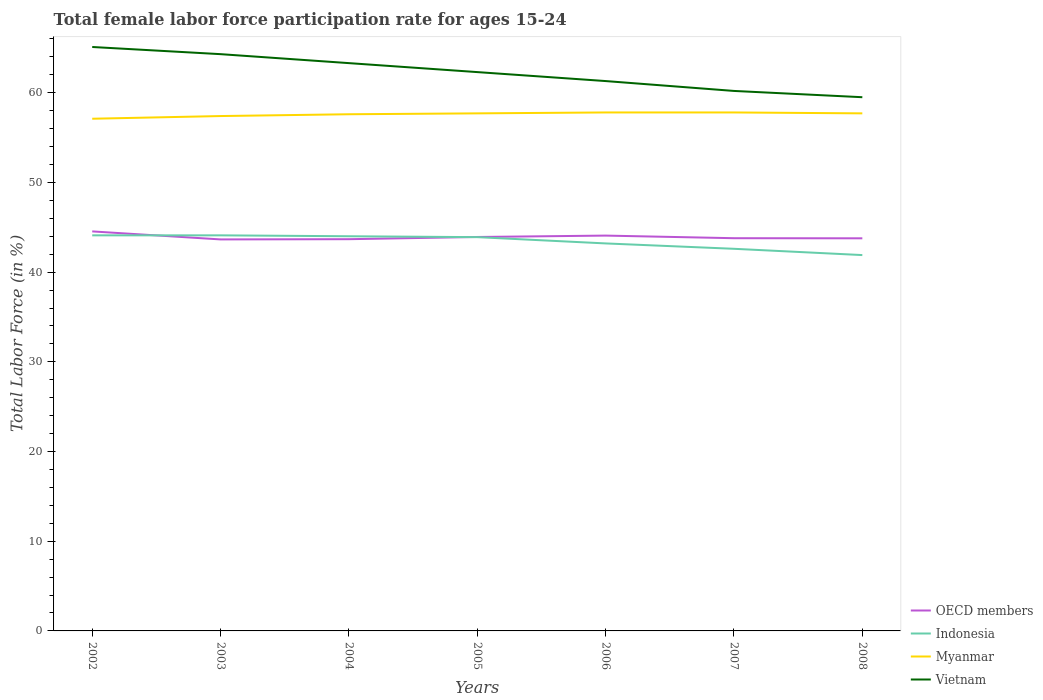How many different coloured lines are there?
Ensure brevity in your answer.  4. Across all years, what is the maximum female labor force participation rate in OECD members?
Keep it short and to the point. 43.65. What is the total female labor force participation rate in Vietnam in the graph?
Make the answer very short. 0.8. What is the difference between the highest and the second highest female labor force participation rate in Indonesia?
Ensure brevity in your answer.  2.2. What is the difference between the highest and the lowest female labor force participation rate in Vietnam?
Offer a very short reply. 4. Is the female labor force participation rate in Indonesia strictly greater than the female labor force participation rate in Vietnam over the years?
Offer a very short reply. Yes. How many lines are there?
Your answer should be compact. 4. How many years are there in the graph?
Offer a terse response. 7. Does the graph contain any zero values?
Your response must be concise. No. Where does the legend appear in the graph?
Your response must be concise. Bottom right. How many legend labels are there?
Your answer should be compact. 4. How are the legend labels stacked?
Provide a succinct answer. Vertical. What is the title of the graph?
Provide a short and direct response. Total female labor force participation rate for ages 15-24. Does "Ireland" appear as one of the legend labels in the graph?
Provide a short and direct response. No. What is the label or title of the X-axis?
Make the answer very short. Years. What is the label or title of the Y-axis?
Your answer should be very brief. Total Labor Force (in %). What is the Total Labor Force (in %) of OECD members in 2002?
Keep it short and to the point. 44.54. What is the Total Labor Force (in %) in Indonesia in 2002?
Provide a succinct answer. 44.1. What is the Total Labor Force (in %) in Myanmar in 2002?
Your answer should be very brief. 57.1. What is the Total Labor Force (in %) in Vietnam in 2002?
Keep it short and to the point. 65.1. What is the Total Labor Force (in %) of OECD members in 2003?
Make the answer very short. 43.65. What is the Total Labor Force (in %) of Indonesia in 2003?
Make the answer very short. 44.1. What is the Total Labor Force (in %) of Myanmar in 2003?
Your answer should be very brief. 57.4. What is the Total Labor Force (in %) of Vietnam in 2003?
Your response must be concise. 64.3. What is the Total Labor Force (in %) in OECD members in 2004?
Give a very brief answer. 43.67. What is the Total Labor Force (in %) of Myanmar in 2004?
Provide a succinct answer. 57.6. What is the Total Labor Force (in %) of Vietnam in 2004?
Provide a short and direct response. 63.3. What is the Total Labor Force (in %) of OECD members in 2005?
Your answer should be very brief. 43.92. What is the Total Labor Force (in %) of Indonesia in 2005?
Offer a very short reply. 43.9. What is the Total Labor Force (in %) in Myanmar in 2005?
Ensure brevity in your answer.  57.7. What is the Total Labor Force (in %) in Vietnam in 2005?
Offer a very short reply. 62.3. What is the Total Labor Force (in %) of OECD members in 2006?
Your answer should be compact. 44.07. What is the Total Labor Force (in %) in Indonesia in 2006?
Your answer should be compact. 43.2. What is the Total Labor Force (in %) in Myanmar in 2006?
Provide a succinct answer. 57.8. What is the Total Labor Force (in %) in Vietnam in 2006?
Give a very brief answer. 61.3. What is the Total Labor Force (in %) of OECD members in 2007?
Keep it short and to the point. 43.78. What is the Total Labor Force (in %) in Indonesia in 2007?
Your answer should be very brief. 42.6. What is the Total Labor Force (in %) in Myanmar in 2007?
Provide a short and direct response. 57.8. What is the Total Labor Force (in %) in Vietnam in 2007?
Give a very brief answer. 60.2. What is the Total Labor Force (in %) of OECD members in 2008?
Offer a very short reply. 43.77. What is the Total Labor Force (in %) in Indonesia in 2008?
Make the answer very short. 41.9. What is the Total Labor Force (in %) of Myanmar in 2008?
Provide a succinct answer. 57.7. What is the Total Labor Force (in %) in Vietnam in 2008?
Your answer should be very brief. 59.5. Across all years, what is the maximum Total Labor Force (in %) of OECD members?
Give a very brief answer. 44.54. Across all years, what is the maximum Total Labor Force (in %) of Indonesia?
Your answer should be very brief. 44.1. Across all years, what is the maximum Total Labor Force (in %) in Myanmar?
Provide a short and direct response. 57.8. Across all years, what is the maximum Total Labor Force (in %) of Vietnam?
Keep it short and to the point. 65.1. Across all years, what is the minimum Total Labor Force (in %) of OECD members?
Keep it short and to the point. 43.65. Across all years, what is the minimum Total Labor Force (in %) of Indonesia?
Your answer should be very brief. 41.9. Across all years, what is the minimum Total Labor Force (in %) in Myanmar?
Offer a terse response. 57.1. Across all years, what is the minimum Total Labor Force (in %) in Vietnam?
Provide a short and direct response. 59.5. What is the total Total Labor Force (in %) in OECD members in the graph?
Your answer should be very brief. 307.4. What is the total Total Labor Force (in %) in Indonesia in the graph?
Give a very brief answer. 303.8. What is the total Total Labor Force (in %) of Myanmar in the graph?
Ensure brevity in your answer.  403.1. What is the total Total Labor Force (in %) in Vietnam in the graph?
Your answer should be very brief. 436. What is the difference between the Total Labor Force (in %) of OECD members in 2002 and that in 2003?
Provide a short and direct response. 0.89. What is the difference between the Total Labor Force (in %) of Indonesia in 2002 and that in 2003?
Ensure brevity in your answer.  0. What is the difference between the Total Labor Force (in %) of OECD members in 2002 and that in 2004?
Offer a very short reply. 0.87. What is the difference between the Total Labor Force (in %) of Vietnam in 2002 and that in 2004?
Give a very brief answer. 1.8. What is the difference between the Total Labor Force (in %) of OECD members in 2002 and that in 2005?
Give a very brief answer. 0.62. What is the difference between the Total Labor Force (in %) of Myanmar in 2002 and that in 2005?
Offer a very short reply. -0.6. What is the difference between the Total Labor Force (in %) of OECD members in 2002 and that in 2006?
Make the answer very short. 0.47. What is the difference between the Total Labor Force (in %) of Vietnam in 2002 and that in 2006?
Your response must be concise. 3.8. What is the difference between the Total Labor Force (in %) in OECD members in 2002 and that in 2007?
Keep it short and to the point. 0.76. What is the difference between the Total Labor Force (in %) in Indonesia in 2002 and that in 2007?
Provide a short and direct response. 1.5. What is the difference between the Total Labor Force (in %) of Vietnam in 2002 and that in 2007?
Ensure brevity in your answer.  4.9. What is the difference between the Total Labor Force (in %) in OECD members in 2002 and that in 2008?
Give a very brief answer. 0.77. What is the difference between the Total Labor Force (in %) in Myanmar in 2002 and that in 2008?
Keep it short and to the point. -0.6. What is the difference between the Total Labor Force (in %) in Vietnam in 2002 and that in 2008?
Your answer should be very brief. 5.6. What is the difference between the Total Labor Force (in %) in OECD members in 2003 and that in 2004?
Offer a terse response. -0.03. What is the difference between the Total Labor Force (in %) of Indonesia in 2003 and that in 2004?
Provide a succinct answer. 0.1. What is the difference between the Total Labor Force (in %) in OECD members in 2003 and that in 2005?
Give a very brief answer. -0.27. What is the difference between the Total Labor Force (in %) in Indonesia in 2003 and that in 2005?
Ensure brevity in your answer.  0.2. What is the difference between the Total Labor Force (in %) of OECD members in 2003 and that in 2006?
Keep it short and to the point. -0.43. What is the difference between the Total Labor Force (in %) of OECD members in 2003 and that in 2007?
Ensure brevity in your answer.  -0.14. What is the difference between the Total Labor Force (in %) of Myanmar in 2003 and that in 2007?
Ensure brevity in your answer.  -0.4. What is the difference between the Total Labor Force (in %) of OECD members in 2003 and that in 2008?
Keep it short and to the point. -0.12. What is the difference between the Total Labor Force (in %) of Myanmar in 2003 and that in 2008?
Offer a terse response. -0.3. What is the difference between the Total Labor Force (in %) of OECD members in 2004 and that in 2005?
Offer a very short reply. -0.25. What is the difference between the Total Labor Force (in %) in Vietnam in 2004 and that in 2005?
Give a very brief answer. 1. What is the difference between the Total Labor Force (in %) in OECD members in 2004 and that in 2006?
Offer a very short reply. -0.4. What is the difference between the Total Labor Force (in %) in Indonesia in 2004 and that in 2006?
Offer a very short reply. 0.8. What is the difference between the Total Labor Force (in %) in OECD members in 2004 and that in 2007?
Your answer should be very brief. -0.11. What is the difference between the Total Labor Force (in %) in Vietnam in 2004 and that in 2007?
Offer a terse response. 3.1. What is the difference between the Total Labor Force (in %) of OECD members in 2004 and that in 2008?
Your answer should be compact. -0.1. What is the difference between the Total Labor Force (in %) of Indonesia in 2004 and that in 2008?
Provide a short and direct response. 2.1. What is the difference between the Total Labor Force (in %) of Myanmar in 2004 and that in 2008?
Your answer should be very brief. -0.1. What is the difference between the Total Labor Force (in %) in OECD members in 2005 and that in 2006?
Make the answer very short. -0.15. What is the difference between the Total Labor Force (in %) in Indonesia in 2005 and that in 2006?
Give a very brief answer. 0.7. What is the difference between the Total Labor Force (in %) of OECD members in 2005 and that in 2007?
Offer a very short reply. 0.14. What is the difference between the Total Labor Force (in %) of Myanmar in 2005 and that in 2007?
Offer a very short reply. -0.1. What is the difference between the Total Labor Force (in %) of Vietnam in 2005 and that in 2007?
Ensure brevity in your answer.  2.1. What is the difference between the Total Labor Force (in %) in OECD members in 2005 and that in 2008?
Provide a succinct answer. 0.15. What is the difference between the Total Labor Force (in %) in OECD members in 2006 and that in 2007?
Ensure brevity in your answer.  0.29. What is the difference between the Total Labor Force (in %) of Indonesia in 2006 and that in 2007?
Keep it short and to the point. 0.6. What is the difference between the Total Labor Force (in %) in Myanmar in 2006 and that in 2007?
Your answer should be very brief. 0. What is the difference between the Total Labor Force (in %) of Vietnam in 2006 and that in 2007?
Provide a short and direct response. 1.1. What is the difference between the Total Labor Force (in %) in OECD members in 2006 and that in 2008?
Ensure brevity in your answer.  0.3. What is the difference between the Total Labor Force (in %) of OECD members in 2007 and that in 2008?
Offer a terse response. 0.01. What is the difference between the Total Labor Force (in %) in Indonesia in 2007 and that in 2008?
Offer a terse response. 0.7. What is the difference between the Total Labor Force (in %) in Myanmar in 2007 and that in 2008?
Provide a short and direct response. 0.1. What is the difference between the Total Labor Force (in %) in OECD members in 2002 and the Total Labor Force (in %) in Indonesia in 2003?
Ensure brevity in your answer.  0.44. What is the difference between the Total Labor Force (in %) of OECD members in 2002 and the Total Labor Force (in %) of Myanmar in 2003?
Your answer should be compact. -12.86. What is the difference between the Total Labor Force (in %) in OECD members in 2002 and the Total Labor Force (in %) in Vietnam in 2003?
Your answer should be compact. -19.76. What is the difference between the Total Labor Force (in %) in Indonesia in 2002 and the Total Labor Force (in %) in Vietnam in 2003?
Keep it short and to the point. -20.2. What is the difference between the Total Labor Force (in %) of Myanmar in 2002 and the Total Labor Force (in %) of Vietnam in 2003?
Provide a short and direct response. -7.2. What is the difference between the Total Labor Force (in %) in OECD members in 2002 and the Total Labor Force (in %) in Indonesia in 2004?
Provide a short and direct response. 0.54. What is the difference between the Total Labor Force (in %) in OECD members in 2002 and the Total Labor Force (in %) in Myanmar in 2004?
Provide a short and direct response. -13.06. What is the difference between the Total Labor Force (in %) in OECD members in 2002 and the Total Labor Force (in %) in Vietnam in 2004?
Provide a short and direct response. -18.76. What is the difference between the Total Labor Force (in %) of Indonesia in 2002 and the Total Labor Force (in %) of Vietnam in 2004?
Your answer should be compact. -19.2. What is the difference between the Total Labor Force (in %) of OECD members in 2002 and the Total Labor Force (in %) of Indonesia in 2005?
Ensure brevity in your answer.  0.64. What is the difference between the Total Labor Force (in %) of OECD members in 2002 and the Total Labor Force (in %) of Myanmar in 2005?
Ensure brevity in your answer.  -13.16. What is the difference between the Total Labor Force (in %) of OECD members in 2002 and the Total Labor Force (in %) of Vietnam in 2005?
Provide a succinct answer. -17.76. What is the difference between the Total Labor Force (in %) in Indonesia in 2002 and the Total Labor Force (in %) in Vietnam in 2005?
Offer a terse response. -18.2. What is the difference between the Total Labor Force (in %) in OECD members in 2002 and the Total Labor Force (in %) in Indonesia in 2006?
Give a very brief answer. 1.34. What is the difference between the Total Labor Force (in %) in OECD members in 2002 and the Total Labor Force (in %) in Myanmar in 2006?
Ensure brevity in your answer.  -13.26. What is the difference between the Total Labor Force (in %) of OECD members in 2002 and the Total Labor Force (in %) of Vietnam in 2006?
Ensure brevity in your answer.  -16.76. What is the difference between the Total Labor Force (in %) in Indonesia in 2002 and the Total Labor Force (in %) in Myanmar in 2006?
Provide a succinct answer. -13.7. What is the difference between the Total Labor Force (in %) of Indonesia in 2002 and the Total Labor Force (in %) of Vietnam in 2006?
Provide a short and direct response. -17.2. What is the difference between the Total Labor Force (in %) in Myanmar in 2002 and the Total Labor Force (in %) in Vietnam in 2006?
Give a very brief answer. -4.2. What is the difference between the Total Labor Force (in %) in OECD members in 2002 and the Total Labor Force (in %) in Indonesia in 2007?
Offer a terse response. 1.94. What is the difference between the Total Labor Force (in %) of OECD members in 2002 and the Total Labor Force (in %) of Myanmar in 2007?
Your response must be concise. -13.26. What is the difference between the Total Labor Force (in %) of OECD members in 2002 and the Total Labor Force (in %) of Vietnam in 2007?
Offer a terse response. -15.66. What is the difference between the Total Labor Force (in %) in Indonesia in 2002 and the Total Labor Force (in %) in Myanmar in 2007?
Your answer should be very brief. -13.7. What is the difference between the Total Labor Force (in %) of Indonesia in 2002 and the Total Labor Force (in %) of Vietnam in 2007?
Make the answer very short. -16.1. What is the difference between the Total Labor Force (in %) in Myanmar in 2002 and the Total Labor Force (in %) in Vietnam in 2007?
Keep it short and to the point. -3.1. What is the difference between the Total Labor Force (in %) of OECD members in 2002 and the Total Labor Force (in %) of Indonesia in 2008?
Keep it short and to the point. 2.64. What is the difference between the Total Labor Force (in %) of OECD members in 2002 and the Total Labor Force (in %) of Myanmar in 2008?
Your answer should be compact. -13.16. What is the difference between the Total Labor Force (in %) in OECD members in 2002 and the Total Labor Force (in %) in Vietnam in 2008?
Provide a short and direct response. -14.96. What is the difference between the Total Labor Force (in %) of Indonesia in 2002 and the Total Labor Force (in %) of Vietnam in 2008?
Your answer should be very brief. -15.4. What is the difference between the Total Labor Force (in %) in Myanmar in 2002 and the Total Labor Force (in %) in Vietnam in 2008?
Provide a succinct answer. -2.4. What is the difference between the Total Labor Force (in %) in OECD members in 2003 and the Total Labor Force (in %) in Indonesia in 2004?
Offer a very short reply. -0.35. What is the difference between the Total Labor Force (in %) in OECD members in 2003 and the Total Labor Force (in %) in Myanmar in 2004?
Your answer should be very brief. -13.95. What is the difference between the Total Labor Force (in %) in OECD members in 2003 and the Total Labor Force (in %) in Vietnam in 2004?
Offer a very short reply. -19.65. What is the difference between the Total Labor Force (in %) in Indonesia in 2003 and the Total Labor Force (in %) in Vietnam in 2004?
Make the answer very short. -19.2. What is the difference between the Total Labor Force (in %) in OECD members in 2003 and the Total Labor Force (in %) in Indonesia in 2005?
Ensure brevity in your answer.  -0.25. What is the difference between the Total Labor Force (in %) of OECD members in 2003 and the Total Labor Force (in %) of Myanmar in 2005?
Give a very brief answer. -14.05. What is the difference between the Total Labor Force (in %) in OECD members in 2003 and the Total Labor Force (in %) in Vietnam in 2005?
Ensure brevity in your answer.  -18.65. What is the difference between the Total Labor Force (in %) in Indonesia in 2003 and the Total Labor Force (in %) in Vietnam in 2005?
Your answer should be very brief. -18.2. What is the difference between the Total Labor Force (in %) in Myanmar in 2003 and the Total Labor Force (in %) in Vietnam in 2005?
Give a very brief answer. -4.9. What is the difference between the Total Labor Force (in %) of OECD members in 2003 and the Total Labor Force (in %) of Indonesia in 2006?
Provide a succinct answer. 0.45. What is the difference between the Total Labor Force (in %) of OECD members in 2003 and the Total Labor Force (in %) of Myanmar in 2006?
Ensure brevity in your answer.  -14.15. What is the difference between the Total Labor Force (in %) in OECD members in 2003 and the Total Labor Force (in %) in Vietnam in 2006?
Provide a succinct answer. -17.65. What is the difference between the Total Labor Force (in %) in Indonesia in 2003 and the Total Labor Force (in %) in Myanmar in 2006?
Ensure brevity in your answer.  -13.7. What is the difference between the Total Labor Force (in %) of Indonesia in 2003 and the Total Labor Force (in %) of Vietnam in 2006?
Offer a terse response. -17.2. What is the difference between the Total Labor Force (in %) in Myanmar in 2003 and the Total Labor Force (in %) in Vietnam in 2006?
Your response must be concise. -3.9. What is the difference between the Total Labor Force (in %) in OECD members in 2003 and the Total Labor Force (in %) in Indonesia in 2007?
Give a very brief answer. 1.05. What is the difference between the Total Labor Force (in %) in OECD members in 2003 and the Total Labor Force (in %) in Myanmar in 2007?
Give a very brief answer. -14.15. What is the difference between the Total Labor Force (in %) in OECD members in 2003 and the Total Labor Force (in %) in Vietnam in 2007?
Make the answer very short. -16.55. What is the difference between the Total Labor Force (in %) of Indonesia in 2003 and the Total Labor Force (in %) of Myanmar in 2007?
Your answer should be compact. -13.7. What is the difference between the Total Labor Force (in %) in Indonesia in 2003 and the Total Labor Force (in %) in Vietnam in 2007?
Your response must be concise. -16.1. What is the difference between the Total Labor Force (in %) of Myanmar in 2003 and the Total Labor Force (in %) of Vietnam in 2007?
Provide a succinct answer. -2.8. What is the difference between the Total Labor Force (in %) of OECD members in 2003 and the Total Labor Force (in %) of Indonesia in 2008?
Give a very brief answer. 1.75. What is the difference between the Total Labor Force (in %) in OECD members in 2003 and the Total Labor Force (in %) in Myanmar in 2008?
Provide a succinct answer. -14.05. What is the difference between the Total Labor Force (in %) in OECD members in 2003 and the Total Labor Force (in %) in Vietnam in 2008?
Make the answer very short. -15.85. What is the difference between the Total Labor Force (in %) in Indonesia in 2003 and the Total Labor Force (in %) in Vietnam in 2008?
Your answer should be very brief. -15.4. What is the difference between the Total Labor Force (in %) of Myanmar in 2003 and the Total Labor Force (in %) of Vietnam in 2008?
Your answer should be very brief. -2.1. What is the difference between the Total Labor Force (in %) of OECD members in 2004 and the Total Labor Force (in %) of Indonesia in 2005?
Give a very brief answer. -0.23. What is the difference between the Total Labor Force (in %) in OECD members in 2004 and the Total Labor Force (in %) in Myanmar in 2005?
Your answer should be very brief. -14.03. What is the difference between the Total Labor Force (in %) in OECD members in 2004 and the Total Labor Force (in %) in Vietnam in 2005?
Give a very brief answer. -18.63. What is the difference between the Total Labor Force (in %) of Indonesia in 2004 and the Total Labor Force (in %) of Myanmar in 2005?
Give a very brief answer. -13.7. What is the difference between the Total Labor Force (in %) in Indonesia in 2004 and the Total Labor Force (in %) in Vietnam in 2005?
Offer a terse response. -18.3. What is the difference between the Total Labor Force (in %) in OECD members in 2004 and the Total Labor Force (in %) in Indonesia in 2006?
Provide a succinct answer. 0.47. What is the difference between the Total Labor Force (in %) in OECD members in 2004 and the Total Labor Force (in %) in Myanmar in 2006?
Give a very brief answer. -14.13. What is the difference between the Total Labor Force (in %) in OECD members in 2004 and the Total Labor Force (in %) in Vietnam in 2006?
Keep it short and to the point. -17.63. What is the difference between the Total Labor Force (in %) in Indonesia in 2004 and the Total Labor Force (in %) in Myanmar in 2006?
Offer a terse response. -13.8. What is the difference between the Total Labor Force (in %) in Indonesia in 2004 and the Total Labor Force (in %) in Vietnam in 2006?
Give a very brief answer. -17.3. What is the difference between the Total Labor Force (in %) in OECD members in 2004 and the Total Labor Force (in %) in Indonesia in 2007?
Make the answer very short. 1.07. What is the difference between the Total Labor Force (in %) of OECD members in 2004 and the Total Labor Force (in %) of Myanmar in 2007?
Give a very brief answer. -14.13. What is the difference between the Total Labor Force (in %) in OECD members in 2004 and the Total Labor Force (in %) in Vietnam in 2007?
Offer a very short reply. -16.53. What is the difference between the Total Labor Force (in %) of Indonesia in 2004 and the Total Labor Force (in %) of Myanmar in 2007?
Ensure brevity in your answer.  -13.8. What is the difference between the Total Labor Force (in %) in Indonesia in 2004 and the Total Labor Force (in %) in Vietnam in 2007?
Ensure brevity in your answer.  -16.2. What is the difference between the Total Labor Force (in %) of OECD members in 2004 and the Total Labor Force (in %) of Indonesia in 2008?
Provide a succinct answer. 1.77. What is the difference between the Total Labor Force (in %) of OECD members in 2004 and the Total Labor Force (in %) of Myanmar in 2008?
Your answer should be compact. -14.03. What is the difference between the Total Labor Force (in %) in OECD members in 2004 and the Total Labor Force (in %) in Vietnam in 2008?
Ensure brevity in your answer.  -15.83. What is the difference between the Total Labor Force (in %) of Indonesia in 2004 and the Total Labor Force (in %) of Myanmar in 2008?
Your answer should be compact. -13.7. What is the difference between the Total Labor Force (in %) in Indonesia in 2004 and the Total Labor Force (in %) in Vietnam in 2008?
Your answer should be very brief. -15.5. What is the difference between the Total Labor Force (in %) in OECD members in 2005 and the Total Labor Force (in %) in Indonesia in 2006?
Give a very brief answer. 0.72. What is the difference between the Total Labor Force (in %) in OECD members in 2005 and the Total Labor Force (in %) in Myanmar in 2006?
Give a very brief answer. -13.88. What is the difference between the Total Labor Force (in %) in OECD members in 2005 and the Total Labor Force (in %) in Vietnam in 2006?
Ensure brevity in your answer.  -17.38. What is the difference between the Total Labor Force (in %) in Indonesia in 2005 and the Total Labor Force (in %) in Vietnam in 2006?
Provide a short and direct response. -17.4. What is the difference between the Total Labor Force (in %) in OECD members in 2005 and the Total Labor Force (in %) in Indonesia in 2007?
Provide a short and direct response. 1.32. What is the difference between the Total Labor Force (in %) in OECD members in 2005 and the Total Labor Force (in %) in Myanmar in 2007?
Your response must be concise. -13.88. What is the difference between the Total Labor Force (in %) of OECD members in 2005 and the Total Labor Force (in %) of Vietnam in 2007?
Provide a short and direct response. -16.28. What is the difference between the Total Labor Force (in %) in Indonesia in 2005 and the Total Labor Force (in %) in Myanmar in 2007?
Make the answer very short. -13.9. What is the difference between the Total Labor Force (in %) in Indonesia in 2005 and the Total Labor Force (in %) in Vietnam in 2007?
Offer a very short reply. -16.3. What is the difference between the Total Labor Force (in %) of Myanmar in 2005 and the Total Labor Force (in %) of Vietnam in 2007?
Offer a very short reply. -2.5. What is the difference between the Total Labor Force (in %) in OECD members in 2005 and the Total Labor Force (in %) in Indonesia in 2008?
Keep it short and to the point. 2.02. What is the difference between the Total Labor Force (in %) in OECD members in 2005 and the Total Labor Force (in %) in Myanmar in 2008?
Provide a short and direct response. -13.78. What is the difference between the Total Labor Force (in %) of OECD members in 2005 and the Total Labor Force (in %) of Vietnam in 2008?
Your answer should be compact. -15.58. What is the difference between the Total Labor Force (in %) in Indonesia in 2005 and the Total Labor Force (in %) in Myanmar in 2008?
Offer a very short reply. -13.8. What is the difference between the Total Labor Force (in %) in Indonesia in 2005 and the Total Labor Force (in %) in Vietnam in 2008?
Your answer should be compact. -15.6. What is the difference between the Total Labor Force (in %) of Myanmar in 2005 and the Total Labor Force (in %) of Vietnam in 2008?
Provide a succinct answer. -1.8. What is the difference between the Total Labor Force (in %) of OECD members in 2006 and the Total Labor Force (in %) of Indonesia in 2007?
Keep it short and to the point. 1.47. What is the difference between the Total Labor Force (in %) of OECD members in 2006 and the Total Labor Force (in %) of Myanmar in 2007?
Your answer should be very brief. -13.73. What is the difference between the Total Labor Force (in %) in OECD members in 2006 and the Total Labor Force (in %) in Vietnam in 2007?
Ensure brevity in your answer.  -16.13. What is the difference between the Total Labor Force (in %) in Indonesia in 2006 and the Total Labor Force (in %) in Myanmar in 2007?
Your answer should be compact. -14.6. What is the difference between the Total Labor Force (in %) in Indonesia in 2006 and the Total Labor Force (in %) in Vietnam in 2007?
Provide a short and direct response. -17. What is the difference between the Total Labor Force (in %) of Myanmar in 2006 and the Total Labor Force (in %) of Vietnam in 2007?
Your response must be concise. -2.4. What is the difference between the Total Labor Force (in %) in OECD members in 2006 and the Total Labor Force (in %) in Indonesia in 2008?
Make the answer very short. 2.17. What is the difference between the Total Labor Force (in %) in OECD members in 2006 and the Total Labor Force (in %) in Myanmar in 2008?
Provide a short and direct response. -13.63. What is the difference between the Total Labor Force (in %) in OECD members in 2006 and the Total Labor Force (in %) in Vietnam in 2008?
Your response must be concise. -15.43. What is the difference between the Total Labor Force (in %) of Indonesia in 2006 and the Total Labor Force (in %) of Vietnam in 2008?
Offer a very short reply. -16.3. What is the difference between the Total Labor Force (in %) of Myanmar in 2006 and the Total Labor Force (in %) of Vietnam in 2008?
Your response must be concise. -1.7. What is the difference between the Total Labor Force (in %) in OECD members in 2007 and the Total Labor Force (in %) in Indonesia in 2008?
Ensure brevity in your answer.  1.88. What is the difference between the Total Labor Force (in %) of OECD members in 2007 and the Total Labor Force (in %) of Myanmar in 2008?
Your response must be concise. -13.92. What is the difference between the Total Labor Force (in %) in OECD members in 2007 and the Total Labor Force (in %) in Vietnam in 2008?
Keep it short and to the point. -15.72. What is the difference between the Total Labor Force (in %) in Indonesia in 2007 and the Total Labor Force (in %) in Myanmar in 2008?
Keep it short and to the point. -15.1. What is the difference between the Total Labor Force (in %) of Indonesia in 2007 and the Total Labor Force (in %) of Vietnam in 2008?
Your answer should be very brief. -16.9. What is the difference between the Total Labor Force (in %) in Myanmar in 2007 and the Total Labor Force (in %) in Vietnam in 2008?
Offer a very short reply. -1.7. What is the average Total Labor Force (in %) in OECD members per year?
Your answer should be very brief. 43.91. What is the average Total Labor Force (in %) in Indonesia per year?
Provide a short and direct response. 43.4. What is the average Total Labor Force (in %) in Myanmar per year?
Your answer should be compact. 57.59. What is the average Total Labor Force (in %) of Vietnam per year?
Ensure brevity in your answer.  62.29. In the year 2002, what is the difference between the Total Labor Force (in %) in OECD members and Total Labor Force (in %) in Indonesia?
Ensure brevity in your answer.  0.44. In the year 2002, what is the difference between the Total Labor Force (in %) of OECD members and Total Labor Force (in %) of Myanmar?
Keep it short and to the point. -12.56. In the year 2002, what is the difference between the Total Labor Force (in %) of OECD members and Total Labor Force (in %) of Vietnam?
Your answer should be compact. -20.56. In the year 2003, what is the difference between the Total Labor Force (in %) of OECD members and Total Labor Force (in %) of Indonesia?
Provide a short and direct response. -0.45. In the year 2003, what is the difference between the Total Labor Force (in %) of OECD members and Total Labor Force (in %) of Myanmar?
Your answer should be very brief. -13.75. In the year 2003, what is the difference between the Total Labor Force (in %) in OECD members and Total Labor Force (in %) in Vietnam?
Provide a succinct answer. -20.65. In the year 2003, what is the difference between the Total Labor Force (in %) of Indonesia and Total Labor Force (in %) of Vietnam?
Your response must be concise. -20.2. In the year 2004, what is the difference between the Total Labor Force (in %) of OECD members and Total Labor Force (in %) of Indonesia?
Make the answer very short. -0.33. In the year 2004, what is the difference between the Total Labor Force (in %) in OECD members and Total Labor Force (in %) in Myanmar?
Provide a succinct answer. -13.93. In the year 2004, what is the difference between the Total Labor Force (in %) in OECD members and Total Labor Force (in %) in Vietnam?
Give a very brief answer. -19.63. In the year 2004, what is the difference between the Total Labor Force (in %) in Indonesia and Total Labor Force (in %) in Vietnam?
Ensure brevity in your answer.  -19.3. In the year 2005, what is the difference between the Total Labor Force (in %) of OECD members and Total Labor Force (in %) of Indonesia?
Ensure brevity in your answer.  0.02. In the year 2005, what is the difference between the Total Labor Force (in %) of OECD members and Total Labor Force (in %) of Myanmar?
Provide a short and direct response. -13.78. In the year 2005, what is the difference between the Total Labor Force (in %) in OECD members and Total Labor Force (in %) in Vietnam?
Your response must be concise. -18.38. In the year 2005, what is the difference between the Total Labor Force (in %) in Indonesia and Total Labor Force (in %) in Myanmar?
Give a very brief answer. -13.8. In the year 2005, what is the difference between the Total Labor Force (in %) in Indonesia and Total Labor Force (in %) in Vietnam?
Keep it short and to the point. -18.4. In the year 2006, what is the difference between the Total Labor Force (in %) in OECD members and Total Labor Force (in %) in Indonesia?
Make the answer very short. 0.87. In the year 2006, what is the difference between the Total Labor Force (in %) in OECD members and Total Labor Force (in %) in Myanmar?
Your answer should be compact. -13.73. In the year 2006, what is the difference between the Total Labor Force (in %) of OECD members and Total Labor Force (in %) of Vietnam?
Offer a terse response. -17.23. In the year 2006, what is the difference between the Total Labor Force (in %) in Indonesia and Total Labor Force (in %) in Myanmar?
Your answer should be compact. -14.6. In the year 2006, what is the difference between the Total Labor Force (in %) of Indonesia and Total Labor Force (in %) of Vietnam?
Give a very brief answer. -18.1. In the year 2006, what is the difference between the Total Labor Force (in %) of Myanmar and Total Labor Force (in %) of Vietnam?
Offer a very short reply. -3.5. In the year 2007, what is the difference between the Total Labor Force (in %) of OECD members and Total Labor Force (in %) of Indonesia?
Offer a very short reply. 1.18. In the year 2007, what is the difference between the Total Labor Force (in %) in OECD members and Total Labor Force (in %) in Myanmar?
Provide a succinct answer. -14.02. In the year 2007, what is the difference between the Total Labor Force (in %) of OECD members and Total Labor Force (in %) of Vietnam?
Provide a short and direct response. -16.42. In the year 2007, what is the difference between the Total Labor Force (in %) of Indonesia and Total Labor Force (in %) of Myanmar?
Ensure brevity in your answer.  -15.2. In the year 2007, what is the difference between the Total Labor Force (in %) of Indonesia and Total Labor Force (in %) of Vietnam?
Offer a terse response. -17.6. In the year 2007, what is the difference between the Total Labor Force (in %) of Myanmar and Total Labor Force (in %) of Vietnam?
Your answer should be compact. -2.4. In the year 2008, what is the difference between the Total Labor Force (in %) of OECD members and Total Labor Force (in %) of Indonesia?
Provide a succinct answer. 1.87. In the year 2008, what is the difference between the Total Labor Force (in %) in OECD members and Total Labor Force (in %) in Myanmar?
Your answer should be compact. -13.93. In the year 2008, what is the difference between the Total Labor Force (in %) in OECD members and Total Labor Force (in %) in Vietnam?
Give a very brief answer. -15.73. In the year 2008, what is the difference between the Total Labor Force (in %) in Indonesia and Total Labor Force (in %) in Myanmar?
Keep it short and to the point. -15.8. In the year 2008, what is the difference between the Total Labor Force (in %) in Indonesia and Total Labor Force (in %) in Vietnam?
Offer a very short reply. -17.6. What is the ratio of the Total Labor Force (in %) in OECD members in 2002 to that in 2003?
Make the answer very short. 1.02. What is the ratio of the Total Labor Force (in %) of Indonesia in 2002 to that in 2003?
Provide a short and direct response. 1. What is the ratio of the Total Labor Force (in %) of Myanmar in 2002 to that in 2003?
Provide a succinct answer. 0.99. What is the ratio of the Total Labor Force (in %) in Vietnam in 2002 to that in 2003?
Keep it short and to the point. 1.01. What is the ratio of the Total Labor Force (in %) in OECD members in 2002 to that in 2004?
Ensure brevity in your answer.  1.02. What is the ratio of the Total Labor Force (in %) in Indonesia in 2002 to that in 2004?
Offer a terse response. 1. What is the ratio of the Total Labor Force (in %) of Myanmar in 2002 to that in 2004?
Your response must be concise. 0.99. What is the ratio of the Total Labor Force (in %) of Vietnam in 2002 to that in 2004?
Make the answer very short. 1.03. What is the ratio of the Total Labor Force (in %) of OECD members in 2002 to that in 2005?
Make the answer very short. 1.01. What is the ratio of the Total Labor Force (in %) in Indonesia in 2002 to that in 2005?
Provide a short and direct response. 1. What is the ratio of the Total Labor Force (in %) in Vietnam in 2002 to that in 2005?
Your response must be concise. 1.04. What is the ratio of the Total Labor Force (in %) of OECD members in 2002 to that in 2006?
Your response must be concise. 1.01. What is the ratio of the Total Labor Force (in %) in Indonesia in 2002 to that in 2006?
Your answer should be compact. 1.02. What is the ratio of the Total Labor Force (in %) in Myanmar in 2002 to that in 2006?
Provide a succinct answer. 0.99. What is the ratio of the Total Labor Force (in %) of Vietnam in 2002 to that in 2006?
Make the answer very short. 1.06. What is the ratio of the Total Labor Force (in %) in OECD members in 2002 to that in 2007?
Your answer should be very brief. 1.02. What is the ratio of the Total Labor Force (in %) in Indonesia in 2002 to that in 2007?
Make the answer very short. 1.04. What is the ratio of the Total Labor Force (in %) of Myanmar in 2002 to that in 2007?
Your answer should be very brief. 0.99. What is the ratio of the Total Labor Force (in %) in Vietnam in 2002 to that in 2007?
Your answer should be compact. 1.08. What is the ratio of the Total Labor Force (in %) of OECD members in 2002 to that in 2008?
Your answer should be very brief. 1.02. What is the ratio of the Total Labor Force (in %) in Indonesia in 2002 to that in 2008?
Make the answer very short. 1.05. What is the ratio of the Total Labor Force (in %) of Myanmar in 2002 to that in 2008?
Your answer should be very brief. 0.99. What is the ratio of the Total Labor Force (in %) of Vietnam in 2002 to that in 2008?
Make the answer very short. 1.09. What is the ratio of the Total Labor Force (in %) in Indonesia in 2003 to that in 2004?
Keep it short and to the point. 1. What is the ratio of the Total Labor Force (in %) of Vietnam in 2003 to that in 2004?
Provide a short and direct response. 1.02. What is the ratio of the Total Labor Force (in %) of OECD members in 2003 to that in 2005?
Give a very brief answer. 0.99. What is the ratio of the Total Labor Force (in %) of Indonesia in 2003 to that in 2005?
Provide a short and direct response. 1. What is the ratio of the Total Labor Force (in %) of Vietnam in 2003 to that in 2005?
Provide a succinct answer. 1.03. What is the ratio of the Total Labor Force (in %) in OECD members in 2003 to that in 2006?
Your answer should be very brief. 0.99. What is the ratio of the Total Labor Force (in %) of Indonesia in 2003 to that in 2006?
Offer a terse response. 1.02. What is the ratio of the Total Labor Force (in %) of Myanmar in 2003 to that in 2006?
Ensure brevity in your answer.  0.99. What is the ratio of the Total Labor Force (in %) in Vietnam in 2003 to that in 2006?
Give a very brief answer. 1.05. What is the ratio of the Total Labor Force (in %) of OECD members in 2003 to that in 2007?
Your answer should be compact. 1. What is the ratio of the Total Labor Force (in %) in Indonesia in 2003 to that in 2007?
Offer a terse response. 1.04. What is the ratio of the Total Labor Force (in %) of Vietnam in 2003 to that in 2007?
Give a very brief answer. 1.07. What is the ratio of the Total Labor Force (in %) in OECD members in 2003 to that in 2008?
Your response must be concise. 1. What is the ratio of the Total Labor Force (in %) in Indonesia in 2003 to that in 2008?
Keep it short and to the point. 1.05. What is the ratio of the Total Labor Force (in %) in Vietnam in 2003 to that in 2008?
Provide a succinct answer. 1.08. What is the ratio of the Total Labor Force (in %) in Vietnam in 2004 to that in 2005?
Provide a short and direct response. 1.02. What is the ratio of the Total Labor Force (in %) in OECD members in 2004 to that in 2006?
Provide a short and direct response. 0.99. What is the ratio of the Total Labor Force (in %) in Indonesia in 2004 to that in 2006?
Make the answer very short. 1.02. What is the ratio of the Total Labor Force (in %) in Vietnam in 2004 to that in 2006?
Offer a very short reply. 1.03. What is the ratio of the Total Labor Force (in %) in Indonesia in 2004 to that in 2007?
Offer a terse response. 1.03. What is the ratio of the Total Labor Force (in %) in Myanmar in 2004 to that in 2007?
Your response must be concise. 1. What is the ratio of the Total Labor Force (in %) of Vietnam in 2004 to that in 2007?
Provide a succinct answer. 1.05. What is the ratio of the Total Labor Force (in %) in OECD members in 2004 to that in 2008?
Your answer should be very brief. 1. What is the ratio of the Total Labor Force (in %) in Indonesia in 2004 to that in 2008?
Give a very brief answer. 1.05. What is the ratio of the Total Labor Force (in %) in Vietnam in 2004 to that in 2008?
Your answer should be very brief. 1.06. What is the ratio of the Total Labor Force (in %) of Indonesia in 2005 to that in 2006?
Offer a terse response. 1.02. What is the ratio of the Total Labor Force (in %) in Myanmar in 2005 to that in 2006?
Provide a short and direct response. 1. What is the ratio of the Total Labor Force (in %) of Vietnam in 2005 to that in 2006?
Provide a short and direct response. 1.02. What is the ratio of the Total Labor Force (in %) of OECD members in 2005 to that in 2007?
Ensure brevity in your answer.  1. What is the ratio of the Total Labor Force (in %) of Indonesia in 2005 to that in 2007?
Keep it short and to the point. 1.03. What is the ratio of the Total Labor Force (in %) in Myanmar in 2005 to that in 2007?
Your response must be concise. 1. What is the ratio of the Total Labor Force (in %) in Vietnam in 2005 to that in 2007?
Ensure brevity in your answer.  1.03. What is the ratio of the Total Labor Force (in %) of OECD members in 2005 to that in 2008?
Your answer should be compact. 1. What is the ratio of the Total Labor Force (in %) in Indonesia in 2005 to that in 2008?
Give a very brief answer. 1.05. What is the ratio of the Total Labor Force (in %) in Myanmar in 2005 to that in 2008?
Your answer should be very brief. 1. What is the ratio of the Total Labor Force (in %) in Vietnam in 2005 to that in 2008?
Offer a very short reply. 1.05. What is the ratio of the Total Labor Force (in %) in OECD members in 2006 to that in 2007?
Ensure brevity in your answer.  1.01. What is the ratio of the Total Labor Force (in %) of Indonesia in 2006 to that in 2007?
Provide a short and direct response. 1.01. What is the ratio of the Total Labor Force (in %) of Vietnam in 2006 to that in 2007?
Give a very brief answer. 1.02. What is the ratio of the Total Labor Force (in %) of OECD members in 2006 to that in 2008?
Give a very brief answer. 1.01. What is the ratio of the Total Labor Force (in %) of Indonesia in 2006 to that in 2008?
Make the answer very short. 1.03. What is the ratio of the Total Labor Force (in %) of Myanmar in 2006 to that in 2008?
Ensure brevity in your answer.  1. What is the ratio of the Total Labor Force (in %) of Vietnam in 2006 to that in 2008?
Your answer should be very brief. 1.03. What is the ratio of the Total Labor Force (in %) of Indonesia in 2007 to that in 2008?
Make the answer very short. 1.02. What is the ratio of the Total Labor Force (in %) in Myanmar in 2007 to that in 2008?
Keep it short and to the point. 1. What is the ratio of the Total Labor Force (in %) in Vietnam in 2007 to that in 2008?
Your answer should be compact. 1.01. What is the difference between the highest and the second highest Total Labor Force (in %) in OECD members?
Your answer should be compact. 0.47. What is the difference between the highest and the second highest Total Labor Force (in %) of Vietnam?
Ensure brevity in your answer.  0.8. What is the difference between the highest and the lowest Total Labor Force (in %) in OECD members?
Make the answer very short. 0.89. What is the difference between the highest and the lowest Total Labor Force (in %) in Indonesia?
Your answer should be very brief. 2.2. What is the difference between the highest and the lowest Total Labor Force (in %) of Myanmar?
Provide a succinct answer. 0.7. 